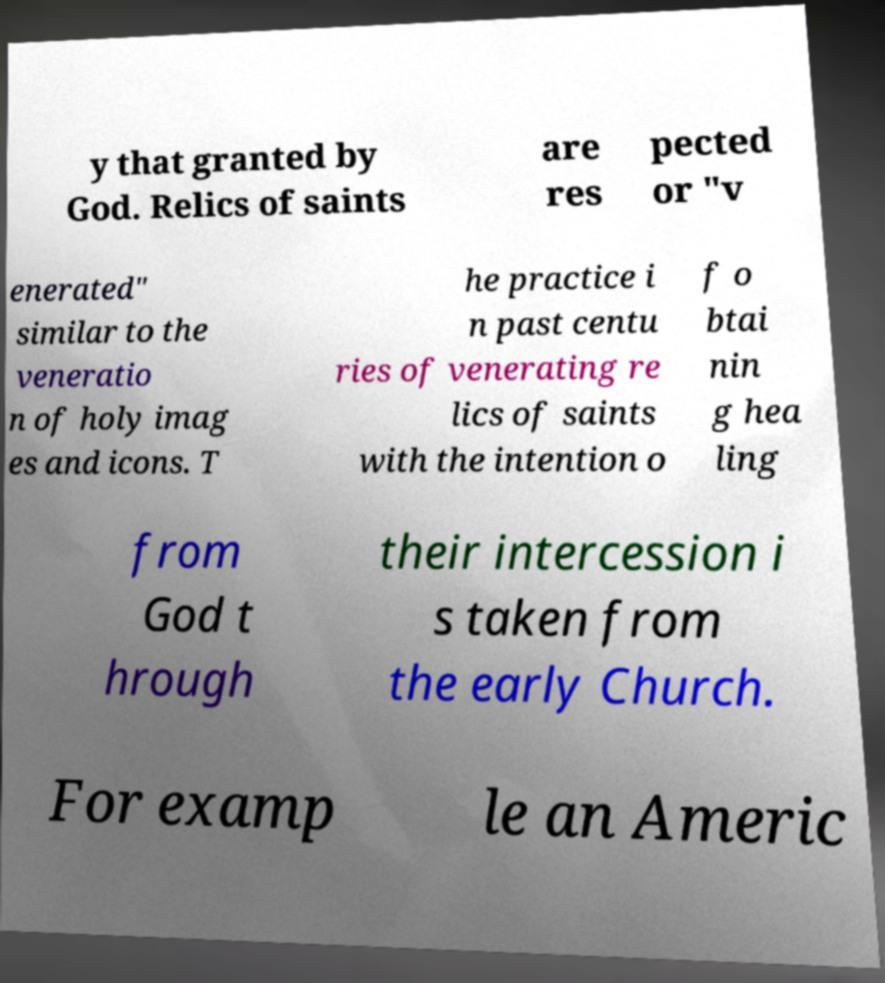For documentation purposes, I need the text within this image transcribed. Could you provide that? y that granted by God. Relics of saints are res pected or "v enerated" similar to the veneratio n of holy imag es and icons. T he practice i n past centu ries of venerating re lics of saints with the intention o f o btai nin g hea ling from God t hrough their intercession i s taken from the early Church. For examp le an Americ 